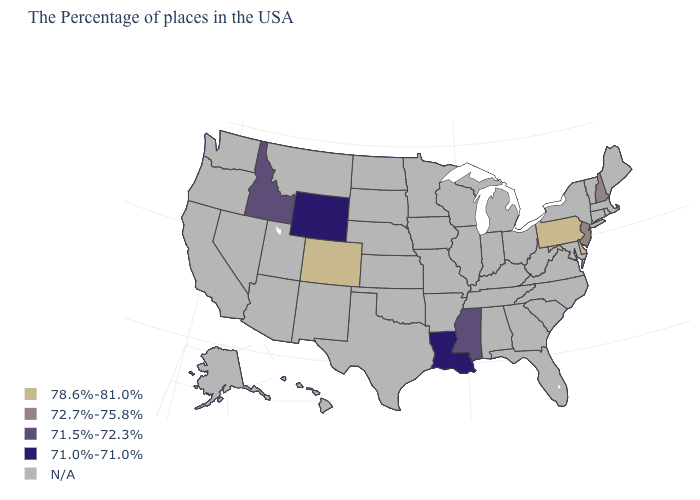What is the highest value in the Northeast ?
Concise answer only. 78.6%-81.0%. Is the legend a continuous bar?
Write a very short answer. No. What is the value of Tennessee?
Keep it brief. N/A. How many symbols are there in the legend?
Short answer required. 5. Name the states that have a value in the range 78.6%-81.0%?
Give a very brief answer. Delaware, Pennsylvania, Colorado. What is the value of New Hampshire?
Keep it brief. 72.7%-75.8%. Name the states that have a value in the range 72.7%-75.8%?
Give a very brief answer. New Hampshire, New Jersey. How many symbols are there in the legend?
Quick response, please. 5. What is the lowest value in the West?
Answer briefly. 71.0%-71.0%. Does the first symbol in the legend represent the smallest category?
Write a very short answer. No. Does Delaware have the highest value in the USA?
Be succinct. Yes. What is the highest value in the West ?
Quick response, please. 78.6%-81.0%. What is the value of North Dakota?
Be succinct. N/A. 